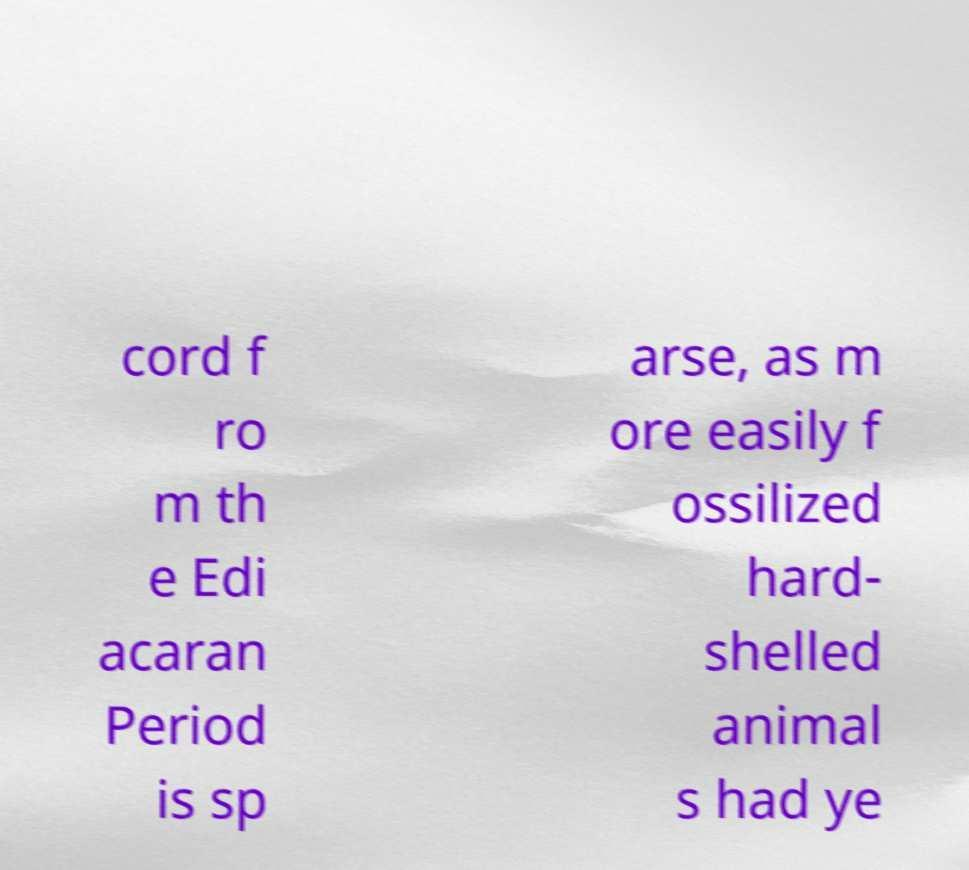Please read and relay the text visible in this image. What does it say? cord f ro m th e Edi acaran Period is sp arse, as m ore easily f ossilized hard- shelled animal s had ye 